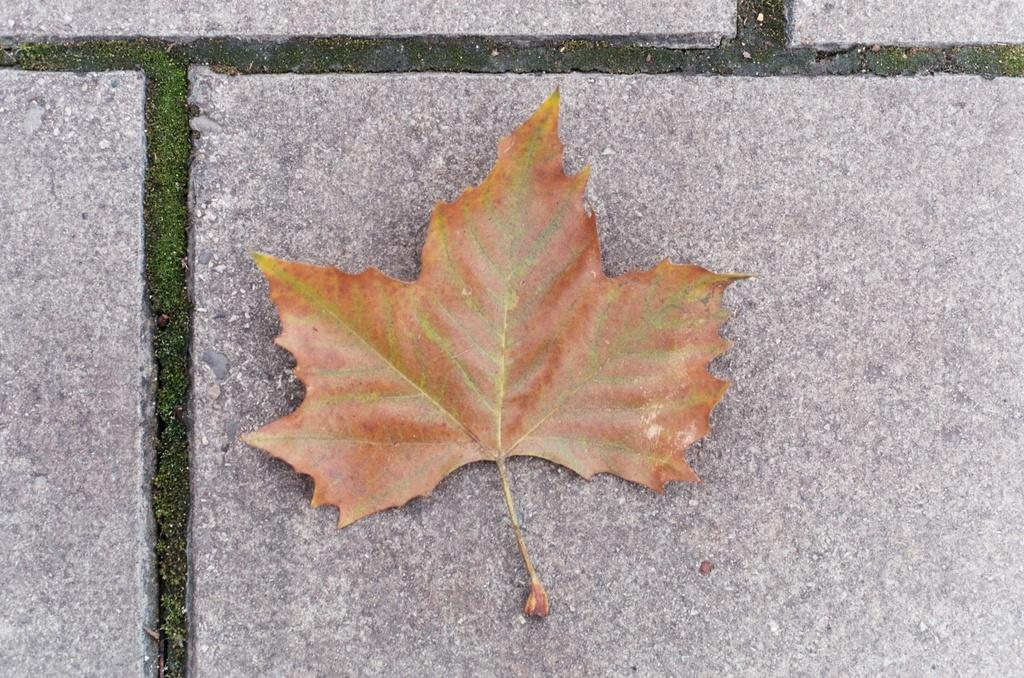What is the main subject of the image? The main subject of the image is a dried leaf. Can you describe the condition of the leaf? The leaf is dried in the image. Where is the dried leaf located? The dried leaf is placed on a surface. What type of company is represented by the dried leaf in the image? The dried leaf does not represent any company in the image. In which country can the dried leaf be found in the image? The image does not provide information about the country where the dried leaf can be found. 